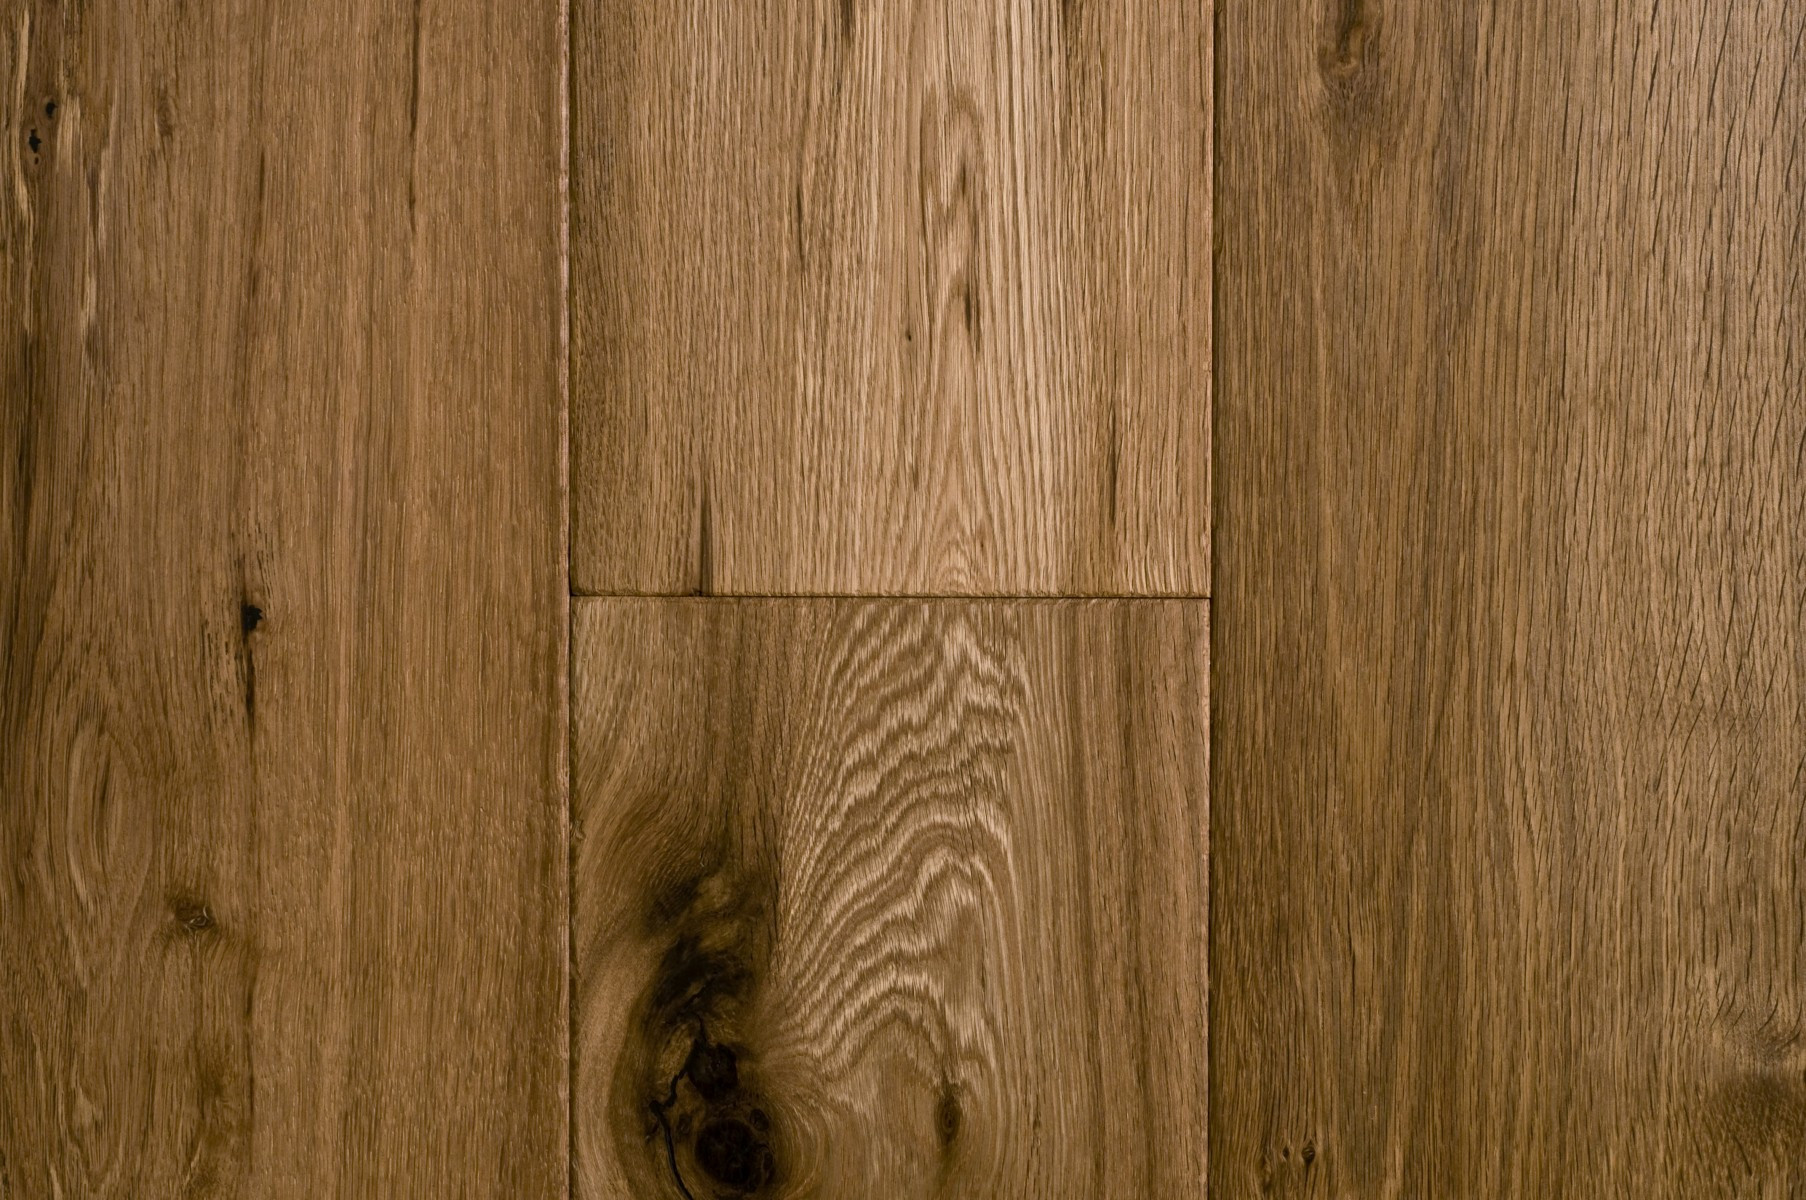How does the quality and characteristics of oak compare to other popular wood types used in flooring? Oak is highly valued for flooring due to its durability, beautiful grain pattern, and resistance to wear, making it suitable for high-traffic areas. Compared to softer woods like pine, oak is more resistant to denting and scratching. Against exotic hardwoods such as teak or mahogany, oak provides a more cost-effective solution while still maintaining a high aesthetic appeal. Oak flooring also typically offers a wider range of finishes and stains than many harder woods, allowing for greater customization to match various interior designs. 